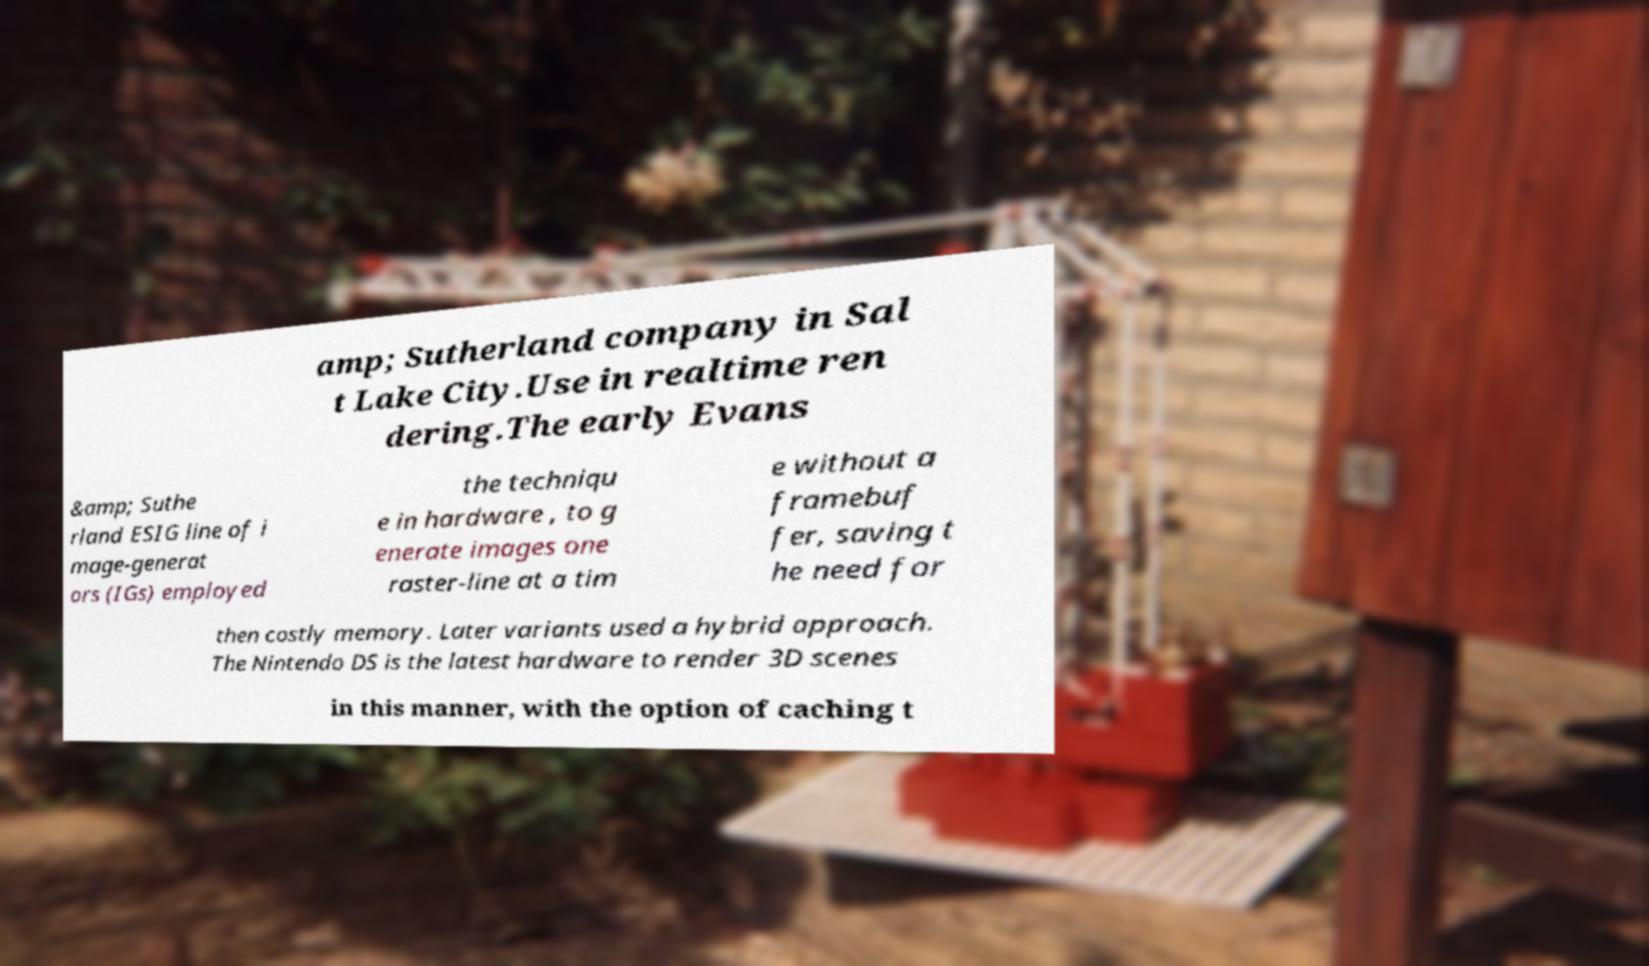There's text embedded in this image that I need extracted. Can you transcribe it verbatim? amp; Sutherland company in Sal t Lake City.Use in realtime ren dering.The early Evans &amp; Suthe rland ESIG line of i mage-generat ors (IGs) employed the techniqu e in hardware , to g enerate images one raster-line at a tim e without a framebuf fer, saving t he need for then costly memory. Later variants used a hybrid approach. The Nintendo DS is the latest hardware to render 3D scenes in this manner, with the option of caching t 